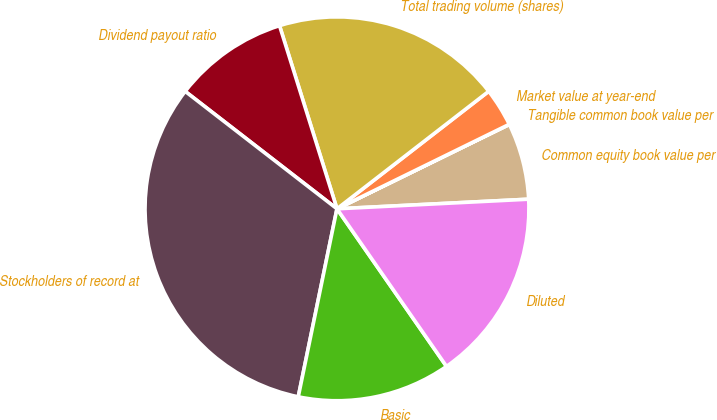Convert chart. <chart><loc_0><loc_0><loc_500><loc_500><pie_chart><fcel>Common equity book value per<fcel>Tangible common book value per<fcel>Market value at year-end<fcel>Total trading volume (shares)<fcel>Dividend payout ratio<fcel>Stockholders of record at<fcel>Basic<fcel>Diluted<nl><fcel>6.45%<fcel>0.01%<fcel>3.23%<fcel>19.35%<fcel>9.68%<fcel>32.25%<fcel>12.9%<fcel>16.13%<nl></chart> 